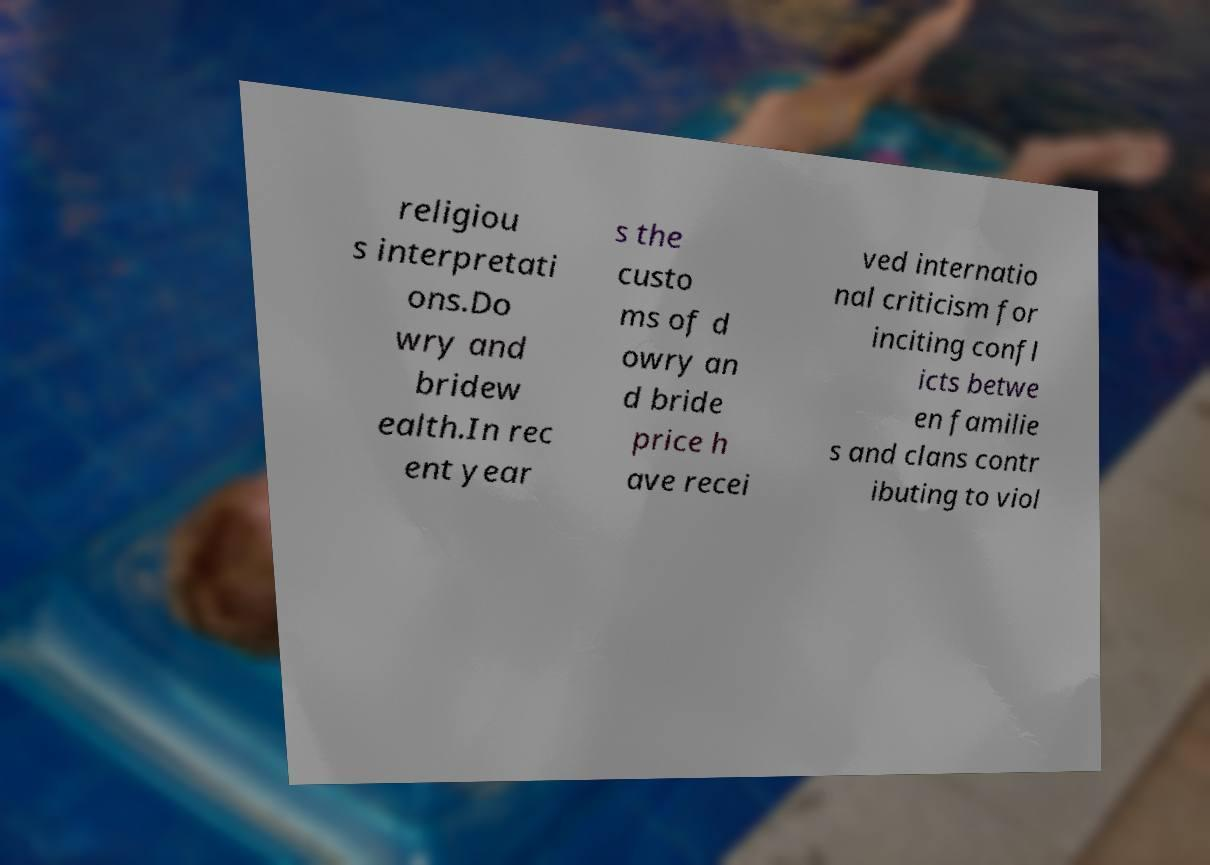Please identify and transcribe the text found in this image. religiou s interpretati ons.Do wry and bridew ealth.In rec ent year s the custo ms of d owry an d bride price h ave recei ved internatio nal criticism for inciting confl icts betwe en familie s and clans contr ibuting to viol 